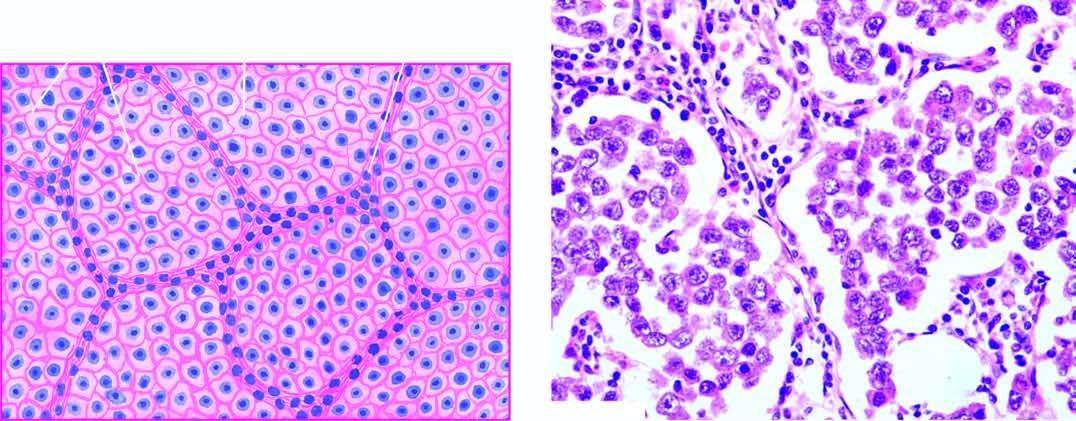does necrosis show lobules of monomorphic seminoma cells separated by delicate fibrous stroma containing lymphocytic infiltration?
Answer the question using a single word or phrase. No 